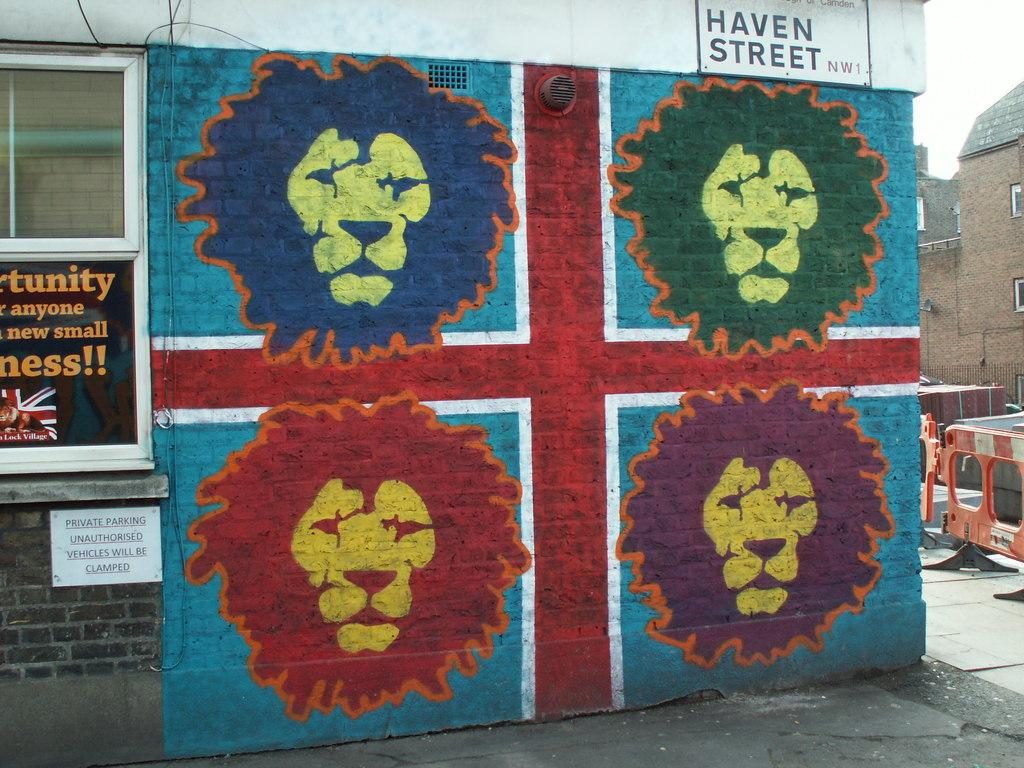Provide a one-sentence caption for the provided image. a lion painting with Haven Street above it. 